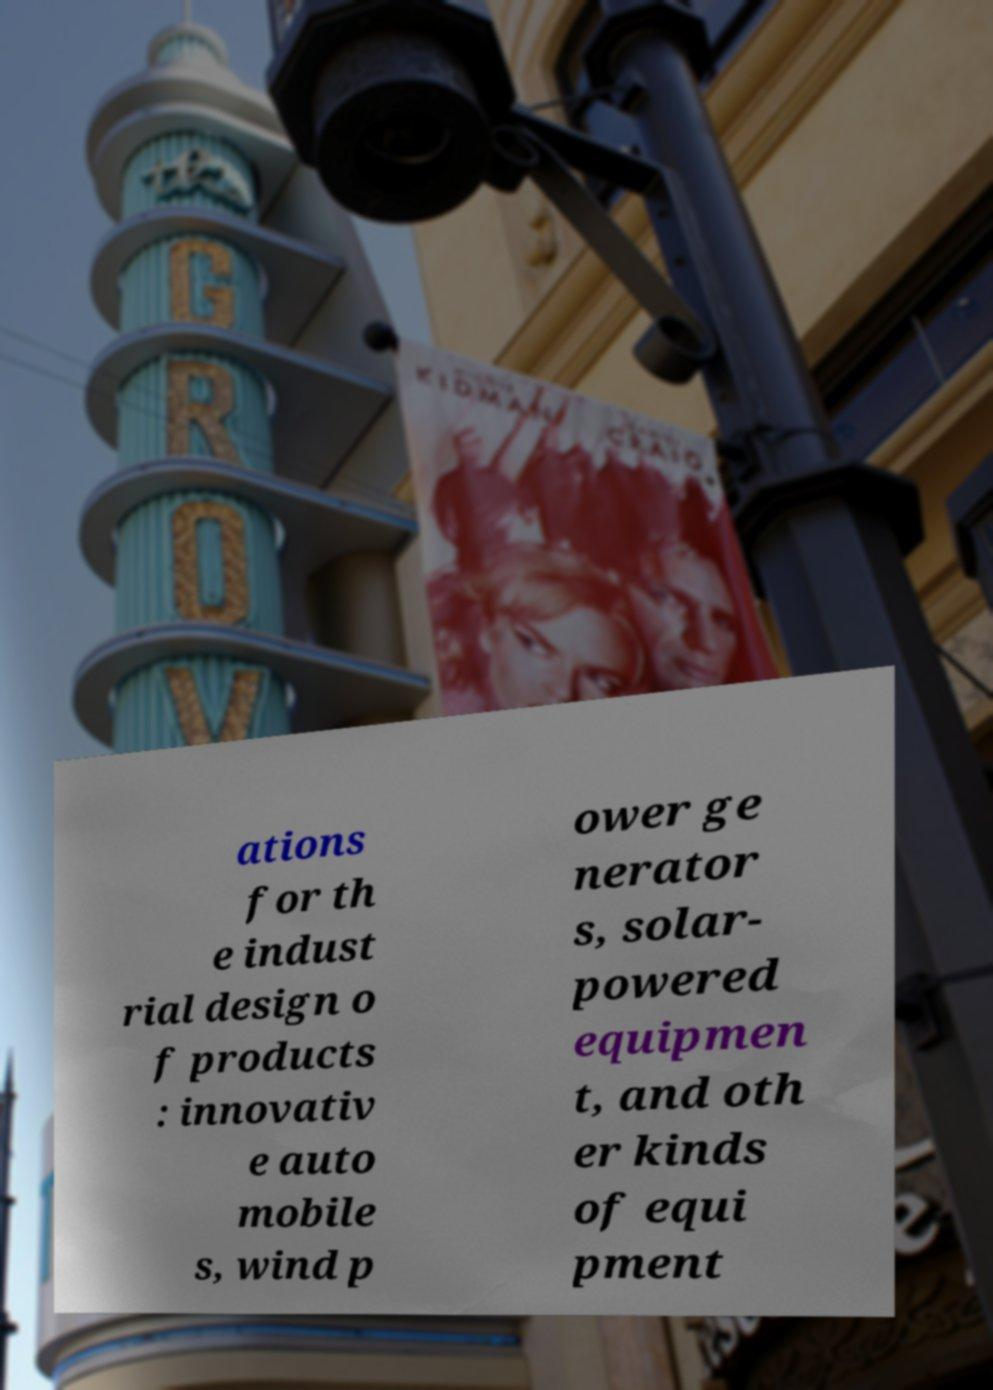Please read and relay the text visible in this image. What does it say? ations for th e indust rial design o f products : innovativ e auto mobile s, wind p ower ge nerator s, solar- powered equipmen t, and oth er kinds of equi pment 